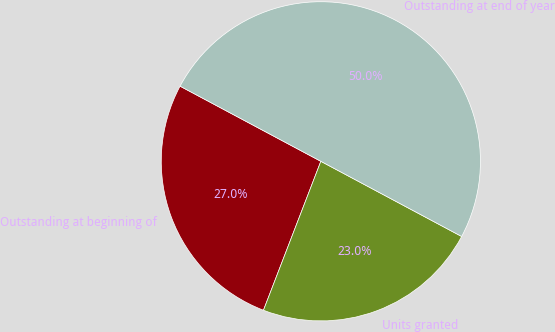Convert chart. <chart><loc_0><loc_0><loc_500><loc_500><pie_chart><fcel>Outstanding at beginning of<fcel>Units granted<fcel>Outstanding at end of year<nl><fcel>26.95%<fcel>23.05%<fcel>50.0%<nl></chart> 